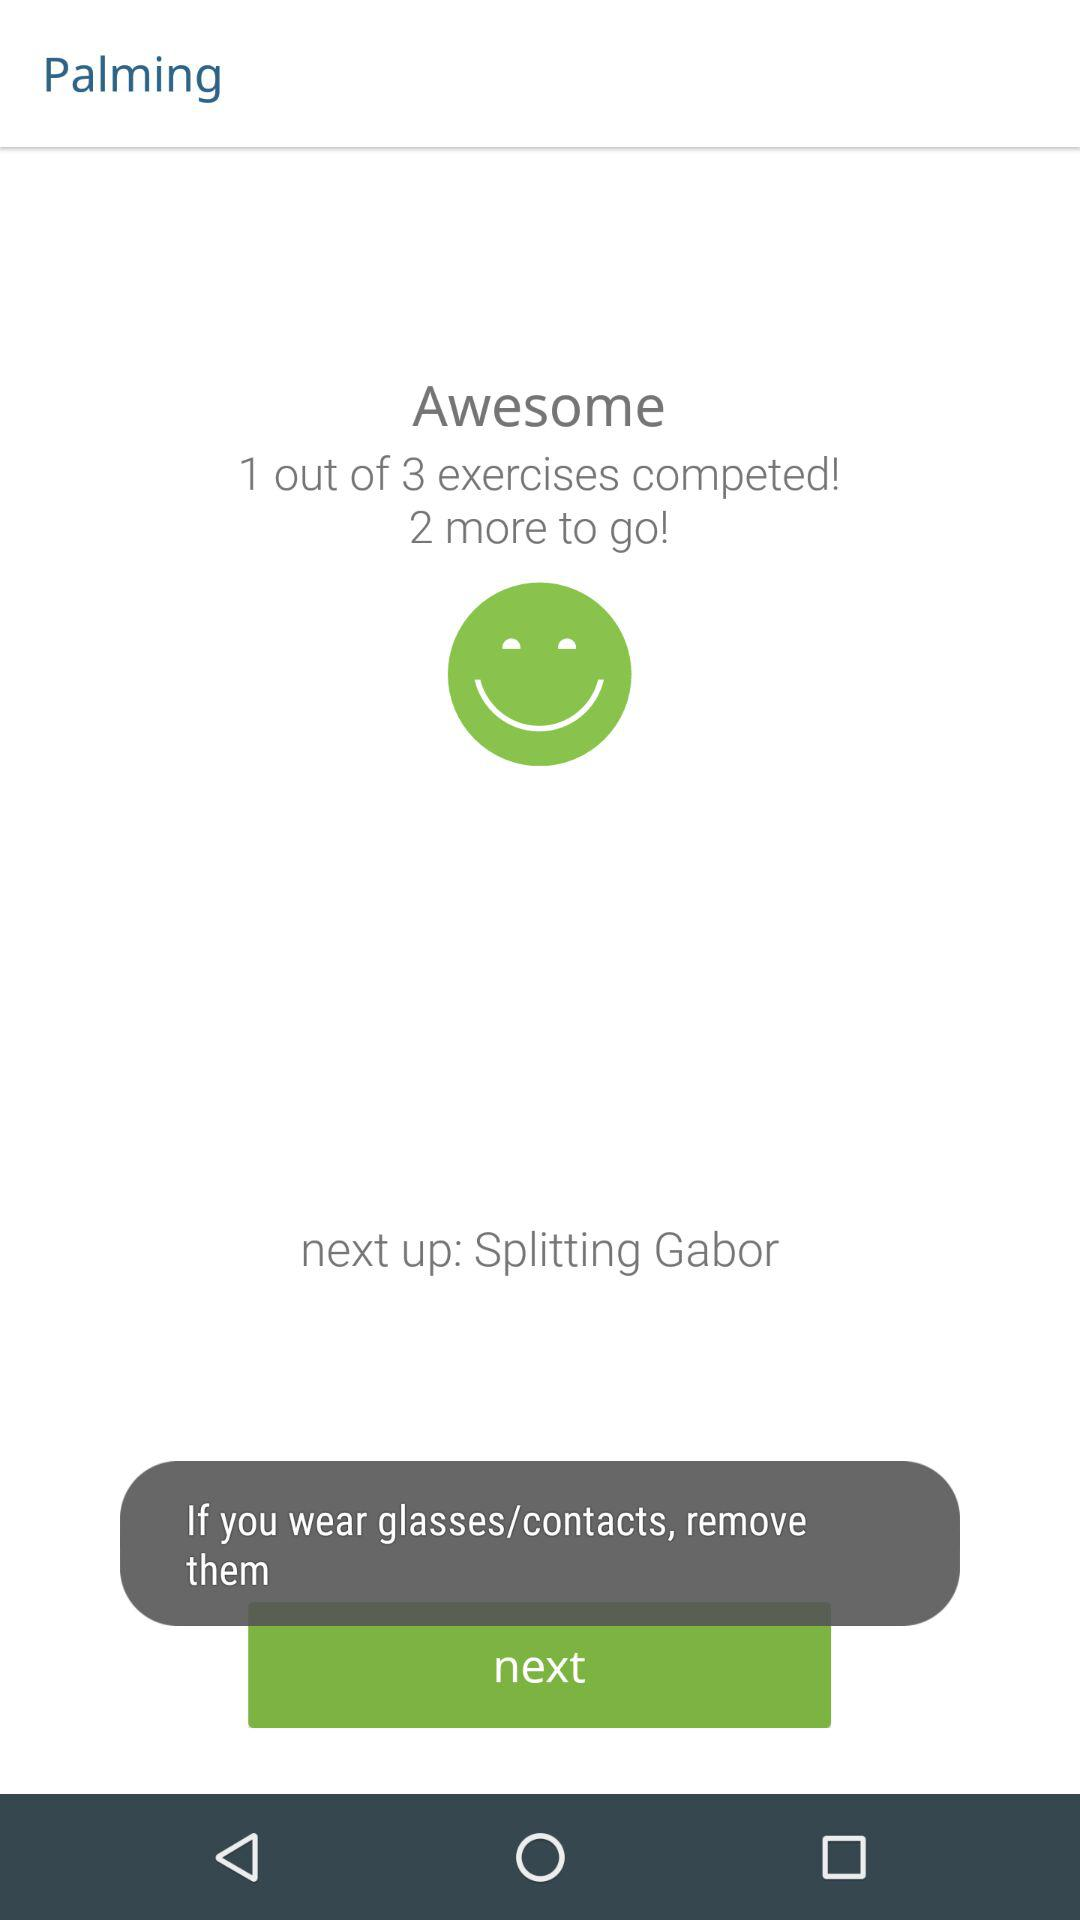How many more exercises are there to go? There are 2 exercises. 